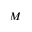<formula> <loc_0><loc_0><loc_500><loc_500>M</formula> 